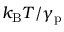<formula> <loc_0><loc_0><loc_500><loc_500>k _ { B } T / \gamma _ { p }</formula> 